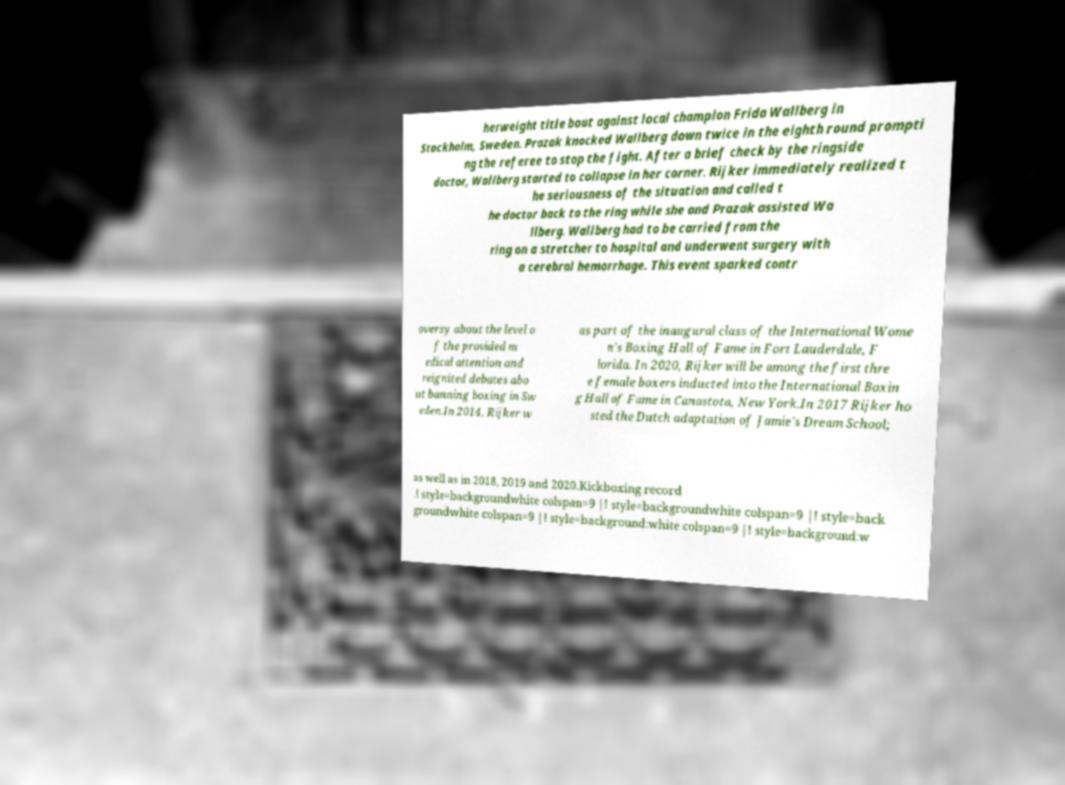What messages or text are displayed in this image? I need them in a readable, typed format. herweight title bout against local champion Frida Wallberg in Stockholm, Sweden. Prazak knocked Wallberg down twice in the eighth round prompti ng the referee to stop the fight. After a brief check by the ringside doctor, Wallberg started to collapse in her corner. Rijker immediately realized t he seriousness of the situation and called t he doctor back to the ring while she and Prazak assisted Wa llberg. Wallberg had to be carried from the ring on a stretcher to hospital and underwent surgery with a cerebral hemorrhage. This event sparked contr oversy about the level o f the provided m edical attention and reignited debates abo ut banning boxing in Sw eden.In 2014, Rijker w as part of the inaugural class of the International Wome n's Boxing Hall of Fame in Fort Lauderdale, F lorida. In 2020, Rijker will be among the first thre e female boxers inducted into the International Boxin g Hall of Fame in Canastota, New York.In 2017 Rijker ho sted the Dutch adaptation of Jamie's Dream School; as well as in 2018, 2019 and 2020.Kickboxing record .! style=backgroundwhite colspan=9 |! style=backgroundwhite colspan=9 |! style=back groundwhite colspan=9 |! style=background:white colspan=9 |! style=background:w 